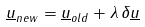Convert formula to latex. <formula><loc_0><loc_0><loc_500><loc_500>\underline { u } _ { n e w } = \underline { u } _ { o l d } + \lambda \, \delta \underline { u }</formula> 